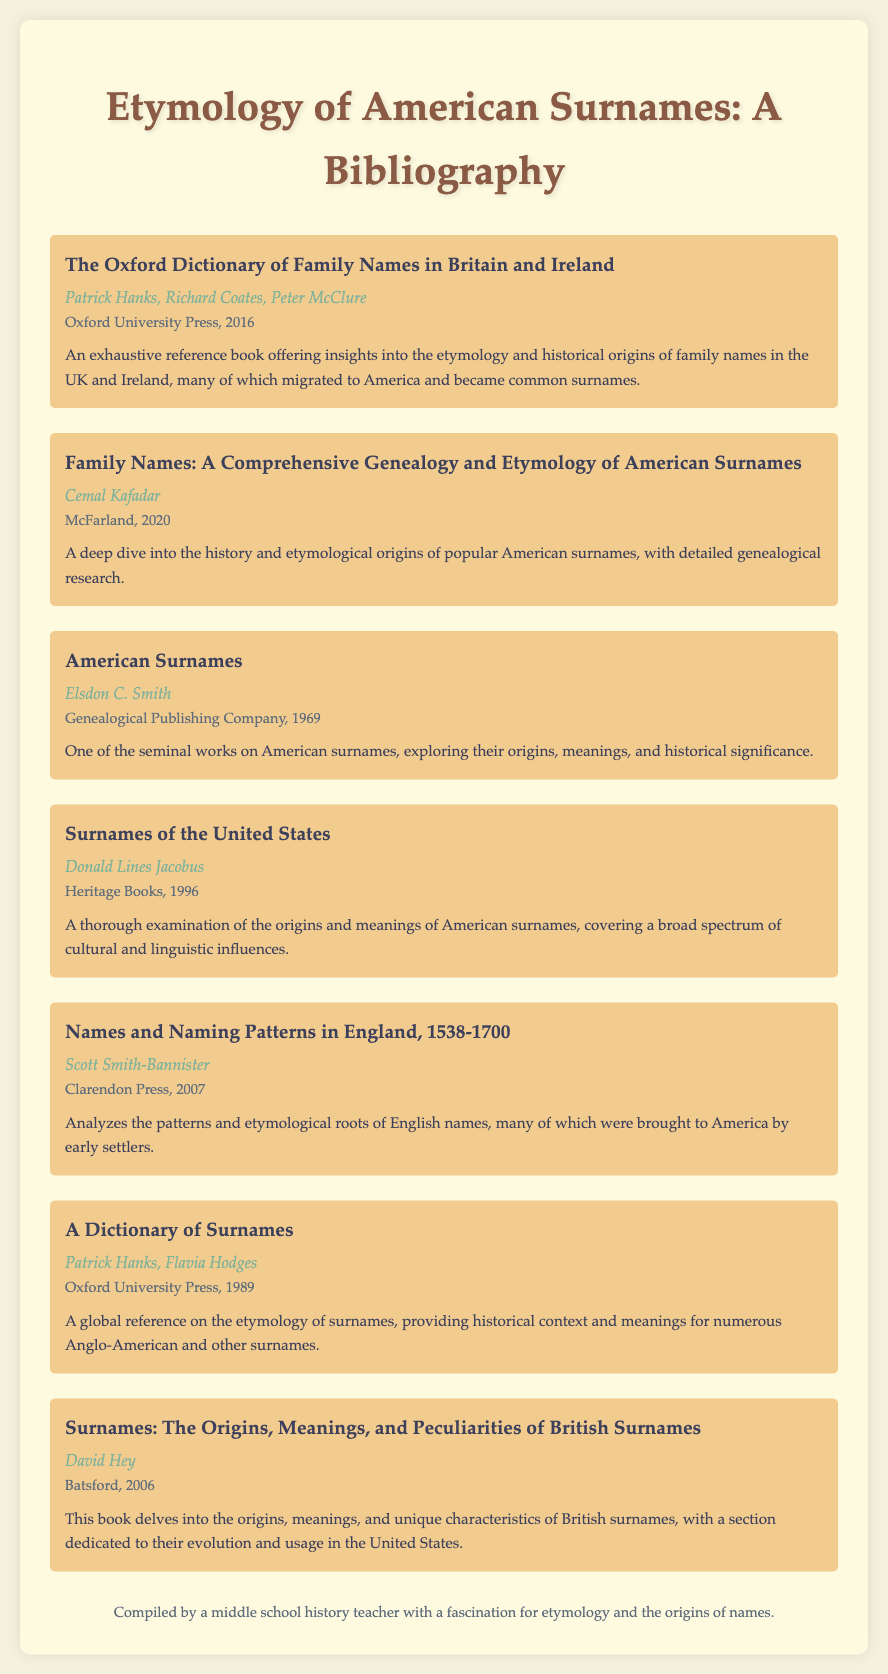What is the title of the first book listed? The title of the first book is mentioned at the top of the bibliography section.
Answer: The Oxford Dictionary of Family Names in Britain and Ireland Who is the author of "Family Names: A Comprehensive Genealogy and Etymology of American Surnames"? The author's name can be found directly below the book title in the bibliography entry.
Answer: Cemal Kafadar What year was "American Surnames" published? The publication year is provided in the information section of the bibliography listing for that book.
Answer: 1969 How many books are listed in the bibliography? The total count of books can be determined by counting each entry in the document.
Answer: Seven What publishing company published "A Dictionary of Surnames"? The publishing company is stated in the details provided for that specific book.
Answer: Oxford University Press Which book focuses on naming patterns in England? The title is mentioned in the list of books provided in the bibliography.
Answer: Names and Naming Patterns in England, 1538-1700 What is the primary topic covered by the bibliography? The overall subject is clear from the title heading of the document.
Answer: Etymology of American Surnames Who compiled this bibliography? The compilers' name can be found in the footer of the document.
Answer: A middle school history teacher with a fascination for etymology and the origins of names 